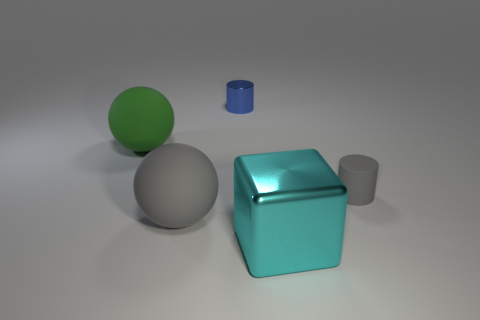What color is the shiny thing that is in front of the big gray sphere?
Offer a very short reply. Cyan. Do the large thing in front of the gray sphere and the blue thing have the same material?
Your answer should be compact. Yes. What number of things are in front of the tiny metallic thing and behind the cyan object?
Ensure brevity in your answer.  3. The tiny cylinder behind the tiny cylinder to the right of the cylinder that is behind the large green ball is what color?
Ensure brevity in your answer.  Blue. What number of other things are there of the same shape as the green object?
Keep it short and to the point. 1. Are there any small blue cylinders in front of the gray sphere on the left side of the cyan metal block?
Offer a terse response. No. How many metal things are either gray cylinders or tiny cyan objects?
Your response must be concise. 0. The thing that is behind the tiny rubber object and right of the large green object is made of what material?
Offer a very short reply. Metal. Is there a large cyan thing left of the matte sphere that is on the right side of the big matte object that is behind the matte cylinder?
Your answer should be compact. No. What shape is the large green object that is made of the same material as the big gray sphere?
Provide a short and direct response. Sphere. 